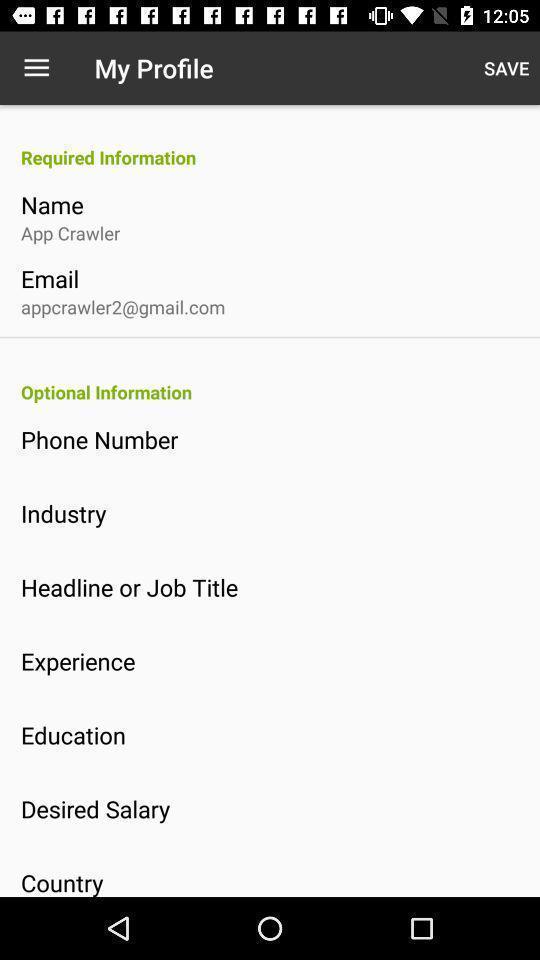Summarize the main components in this picture. Page showing my profile on a job recruitment app. 